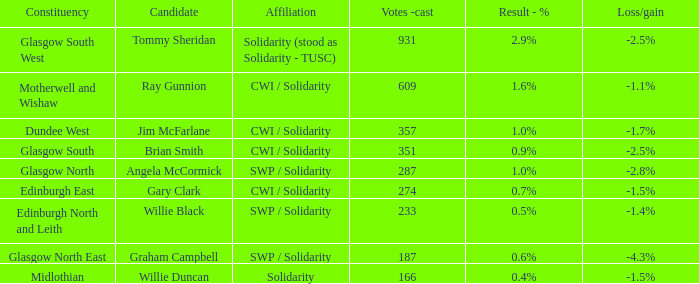Who was the applicant when the conclusion - % was Tommy Sheridan. 